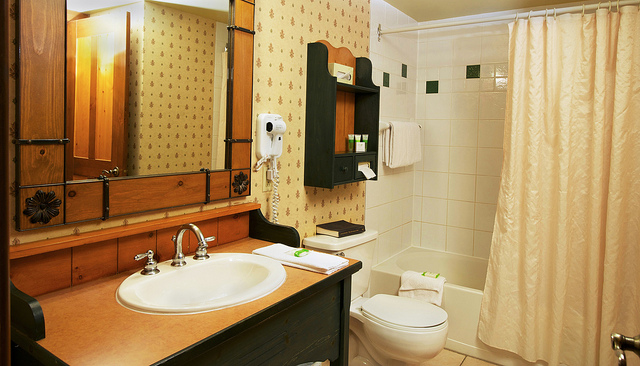What items are provided for guests in this bathroom? Based on the items visible, guests are provided with towels, a bar of soap, and likely some amenities that might be out of view, such as shampoo or toilet paper, which are commonly provided in hotel bathrooms. 